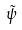<formula> <loc_0><loc_0><loc_500><loc_500>\tilde { \psi }</formula> 